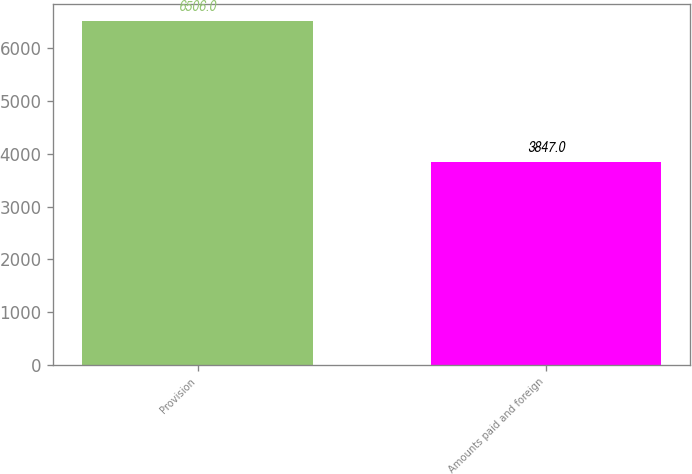Convert chart. <chart><loc_0><loc_0><loc_500><loc_500><bar_chart><fcel>Provision<fcel>Amounts paid and foreign<nl><fcel>6506<fcel>3847<nl></chart> 